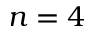<formula> <loc_0><loc_0><loc_500><loc_500>n = 4</formula> 